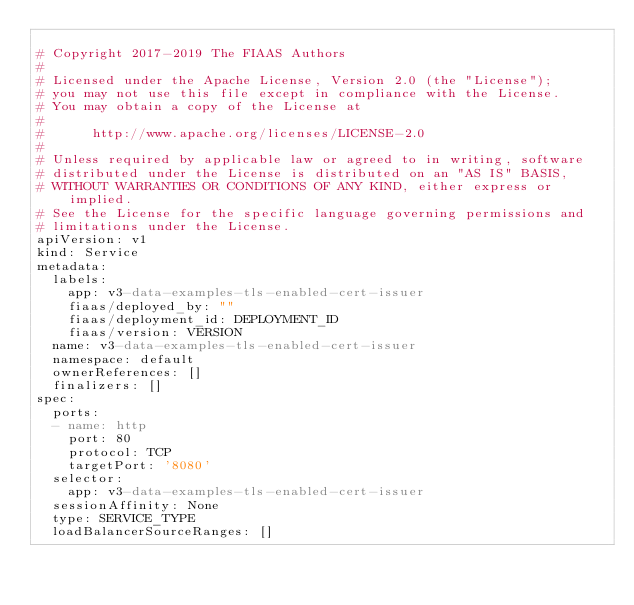Convert code to text. <code><loc_0><loc_0><loc_500><loc_500><_YAML_>
# Copyright 2017-2019 The FIAAS Authors
#
# Licensed under the Apache License, Version 2.0 (the "License");
# you may not use this file except in compliance with the License.
# You may obtain a copy of the License at
#
#      http://www.apache.org/licenses/LICENSE-2.0
#
# Unless required by applicable law or agreed to in writing, software
# distributed under the License is distributed on an "AS IS" BASIS,
# WITHOUT WARRANTIES OR CONDITIONS OF ANY KIND, either express or implied.
# See the License for the specific language governing permissions and
# limitations under the License.
apiVersion: v1
kind: Service
metadata:
  labels:
    app: v3-data-examples-tls-enabled-cert-issuer
    fiaas/deployed_by: ""
    fiaas/deployment_id: DEPLOYMENT_ID
    fiaas/version: VERSION
  name: v3-data-examples-tls-enabled-cert-issuer
  namespace: default
  ownerReferences: []
  finalizers: []
spec:
  ports:
  - name: http
    port: 80
    protocol: TCP
    targetPort: '8080'
  selector:
    app: v3-data-examples-tls-enabled-cert-issuer
  sessionAffinity: None
  type: SERVICE_TYPE
  loadBalancerSourceRanges: []
</code> 